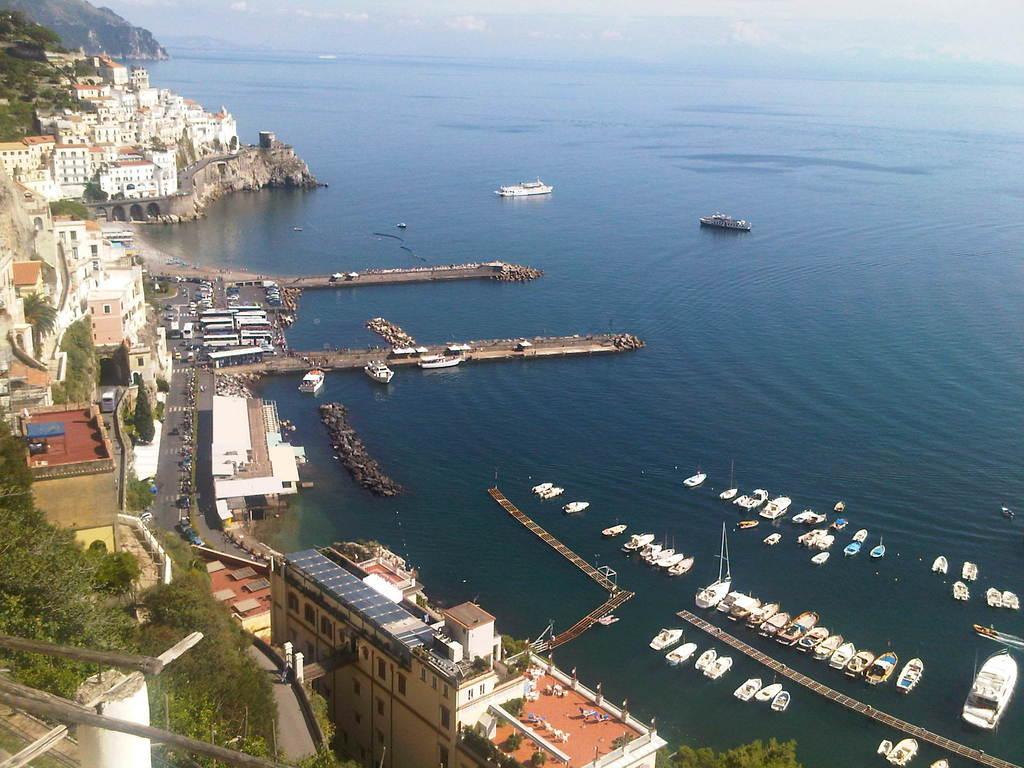Can you describe this image briefly? In the picture I can see few boats on the water in the right corner and there are few buildings,trees and vehicles in the left corner. 